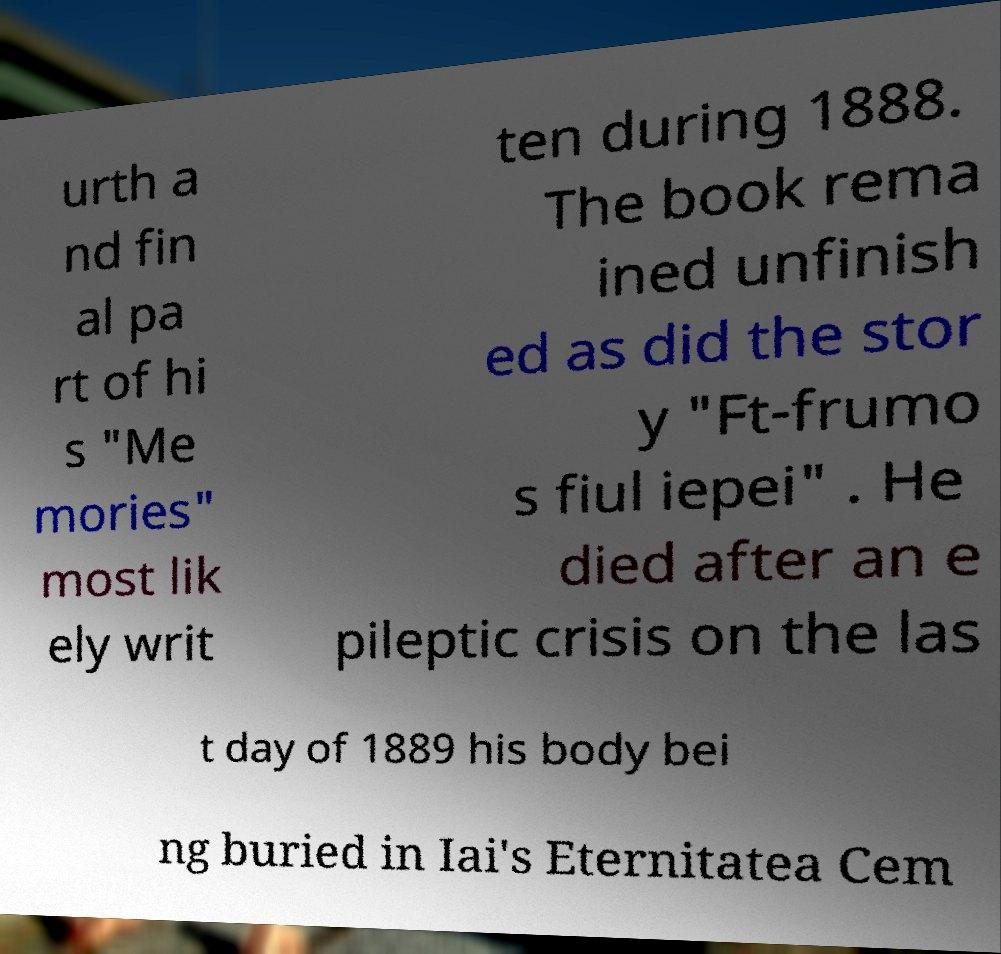For documentation purposes, I need the text within this image transcribed. Could you provide that? urth a nd fin al pa rt of hi s "Me mories" most lik ely writ ten during 1888. The book rema ined unfinish ed as did the stor y "Ft-frumo s fiul iepei" . He died after an e pileptic crisis on the las t day of 1889 his body bei ng buried in Iai's Eternitatea Cem 